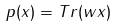Convert formula to latex. <formula><loc_0><loc_0><loc_500><loc_500>p ( x ) = T r ( w x )</formula> 